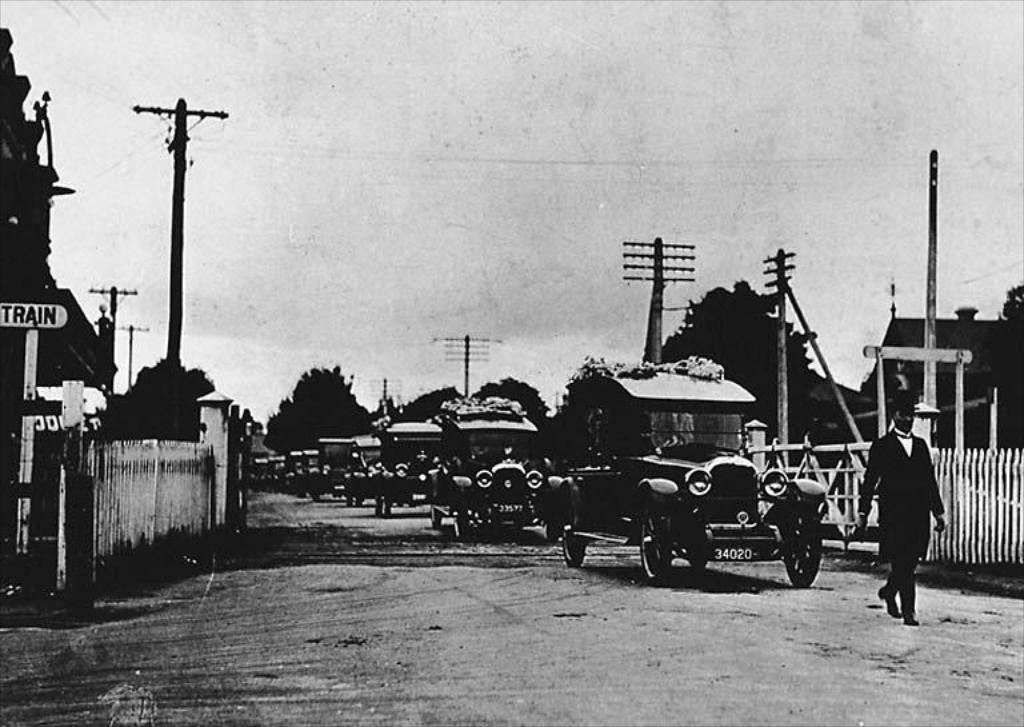Please provide a concise description of this image. In the middle of the image there are some vehicles on the road and a person is walking. Behind them there is fencing. Behind the fencing there are some trees and poles and sign boards. At the top of the image there is sky. 